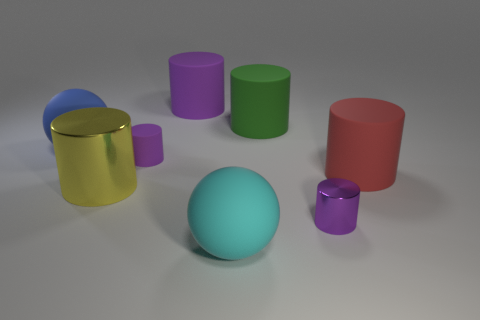How many purple cylinders must be subtracted to get 1 purple cylinders? 2 Subtract all small cylinders. How many cylinders are left? 4 Subtract all red spheres. How many purple cylinders are left? 3 Subtract all green cylinders. How many cylinders are left? 5 Add 2 big things. How many objects exist? 10 Subtract all spheres. How many objects are left? 6 Subtract all gray cylinders. Subtract all blue spheres. How many cylinders are left? 6 Subtract all tiny purple matte objects. Subtract all green things. How many objects are left? 6 Add 1 blue things. How many blue things are left? 2 Add 4 big gray metal spheres. How many big gray metal spheres exist? 4 